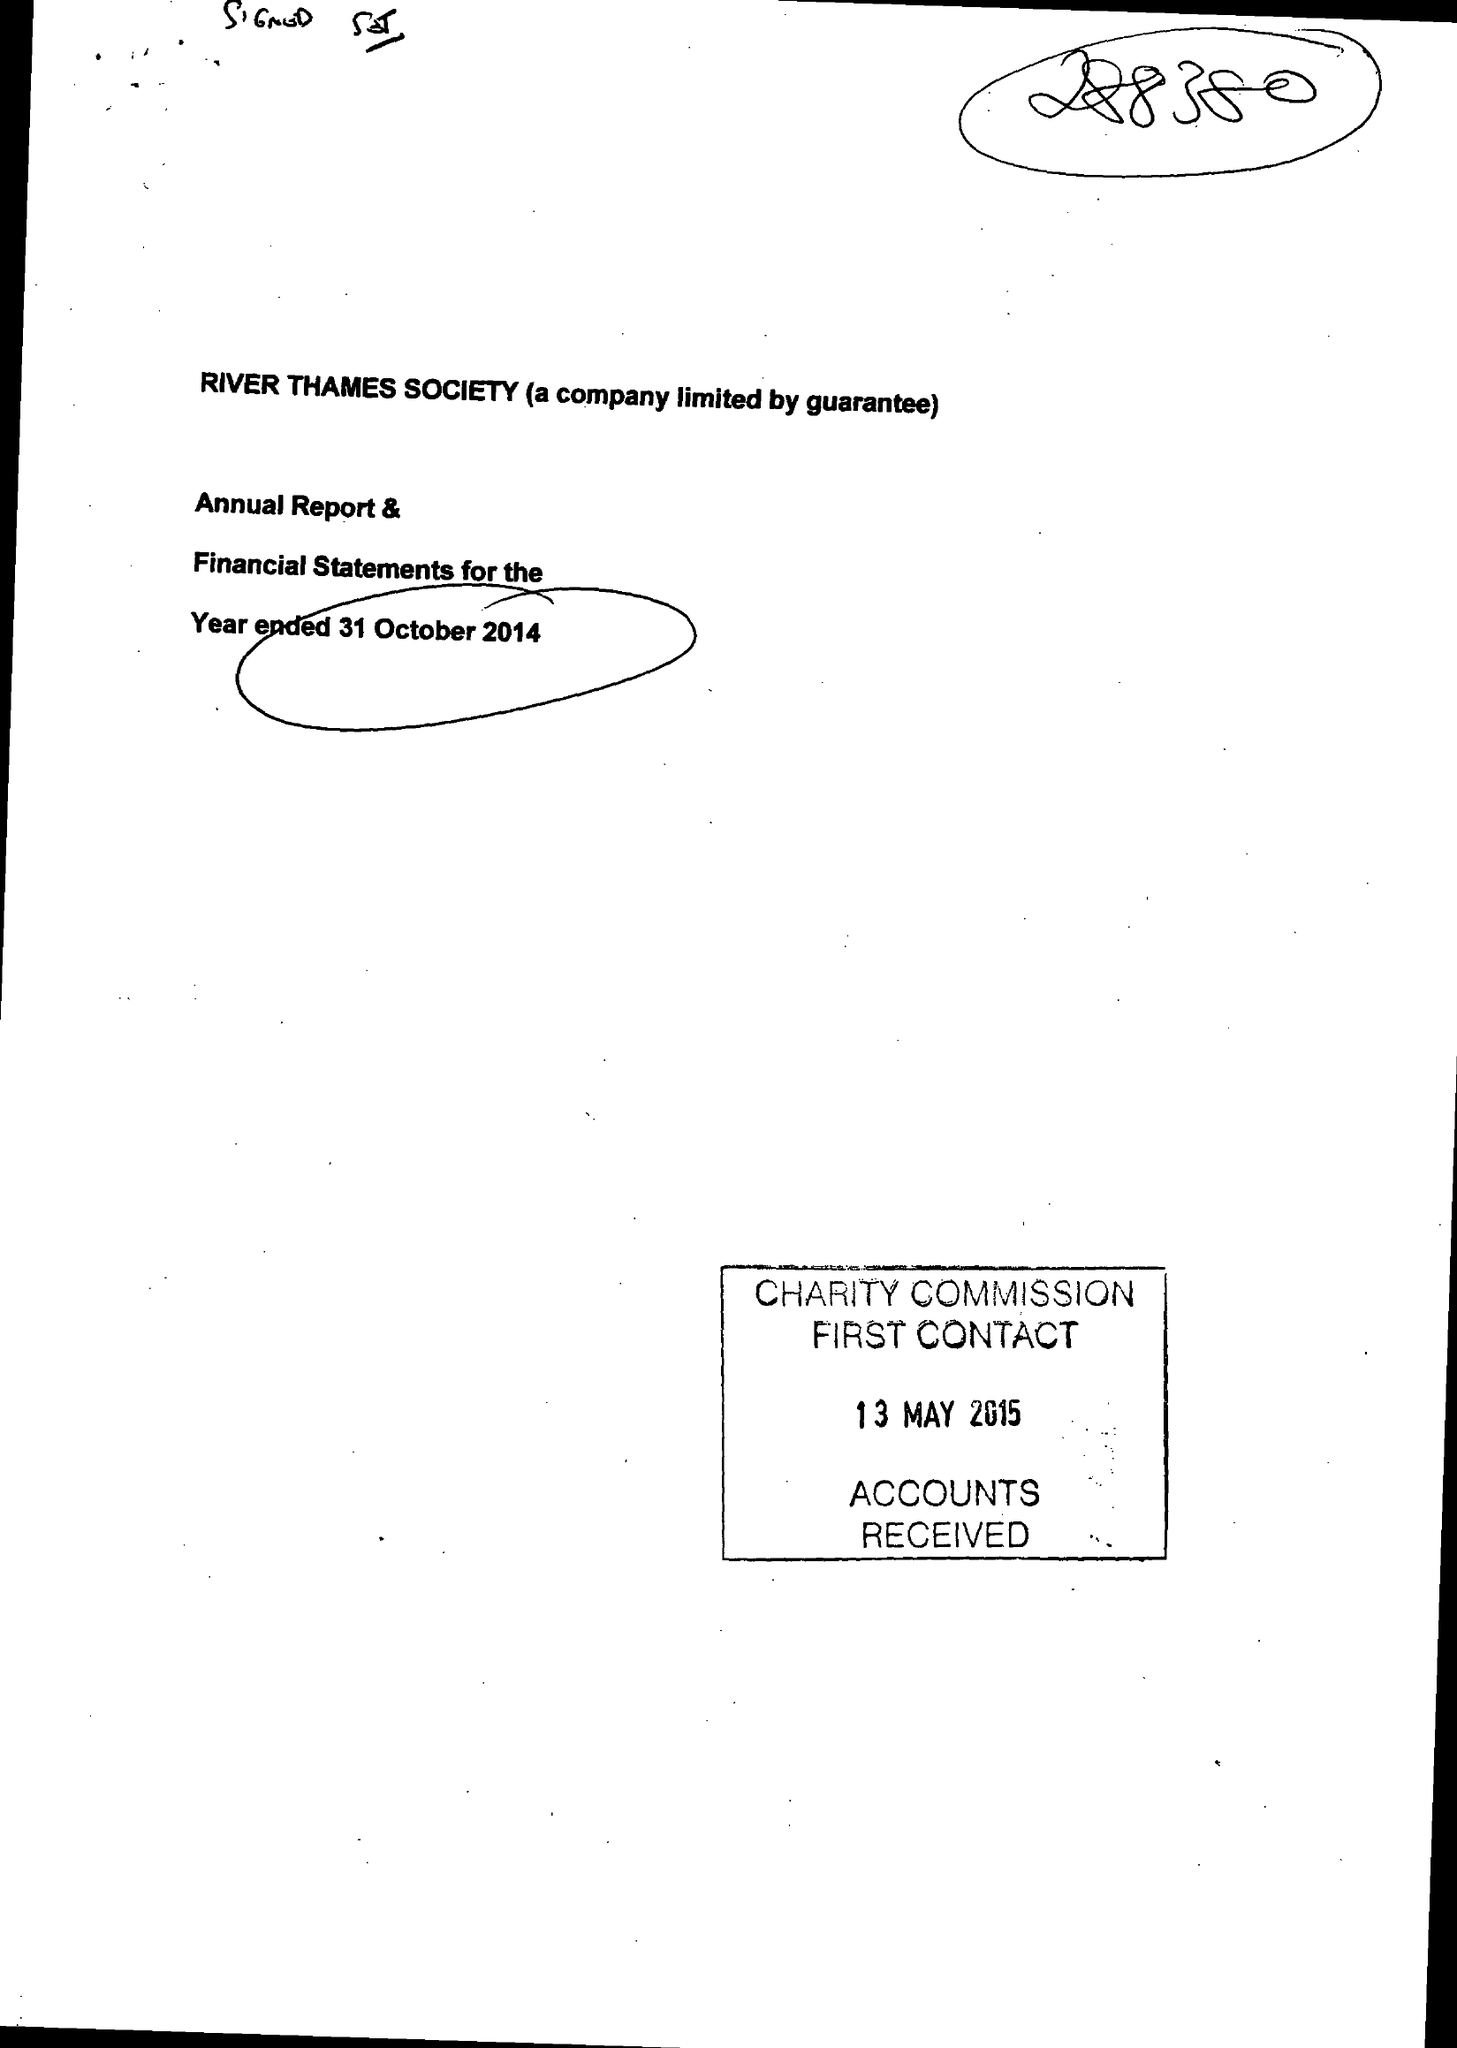What is the value for the spending_annually_in_british_pounds?
Answer the question using a single word or phrase. 35165.00 